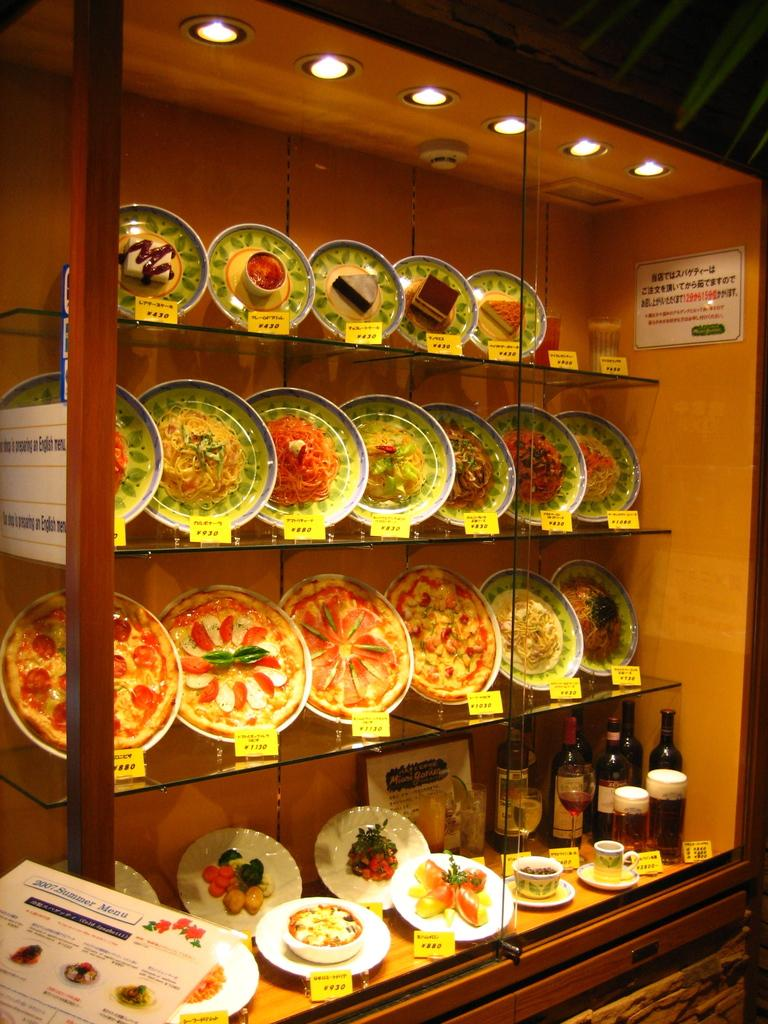What is being covered in the image? There are food items wrapped up in a cover in the image. Where are the food items placed? The food items are displayed on a display cupboard. What else can be seen in the image besides the food items? There are bottles of drinks, cups, and glasses in the image. Can you see a yak in the image? No, there is no yak present in the image. How many arms are visible in the image? There are no arms visible in the image; it features food items, drinks, cups, and glasses. 